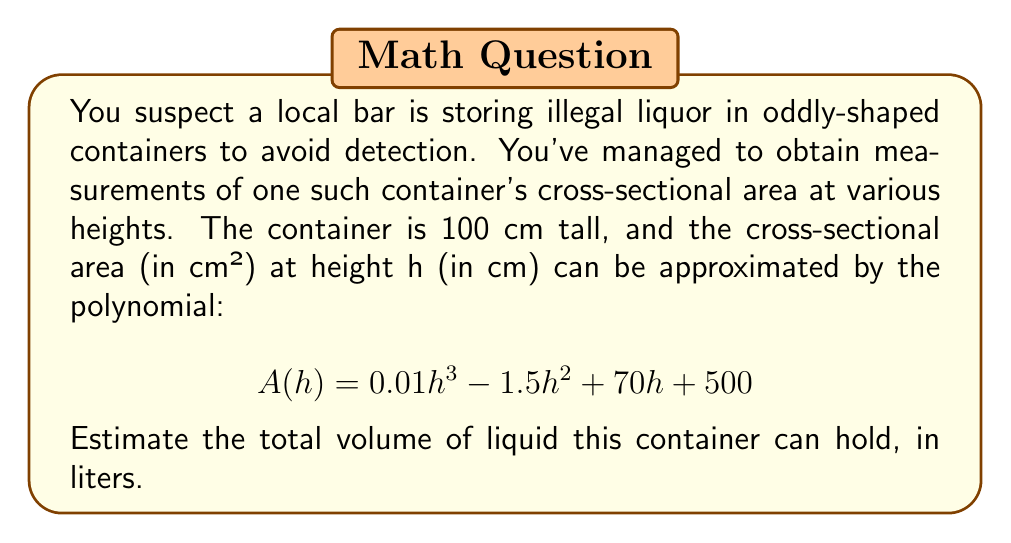Help me with this question. To estimate the volume of the container, we need to integrate the cross-sectional area function over the height of the container. This is because the volume of a solid can be found by integrating its cross-sectional area over its height.

1) The volume V is given by the definite integral:

   $$ V = \int_0^{100} A(h) \, dh $$

2) Substituting the given function:

   $$ V = \int_0^{100} (0.01h^3 - 1.5h^2 + 70h + 500) \, dh $$

3) Integrate term by term:

   $$ V = \left[ \frac{0.01h^4}{4} - \frac{1.5h^3}{3} + \frac{70h^2}{2} + 500h \right]_0^{100} $$

4) Evaluate at the limits:

   $$ V = \left(\frac{0.01(100^4)}{4} - \frac{1.5(100^3)}{3} + \frac{70(100^2)}{2} + 500(100)\right) - \left(0 - 0 + 0 + 0\right) $$

5) Simplify:

   $$ V = 25000 - 500000 + 350000 + 50000 = -75000 $$

6) The result is in cm³. Convert to liters:

   $$ -75000 \text{ cm}^3 \times \frac{1 \text{ L}}{1000 \text{ cm}^3} = -75 \text{ L} $$

7) Since volume cannot be negative, we take the absolute value:

   $$ |V| = 75 \text{ L} $$
Answer: 75 liters 